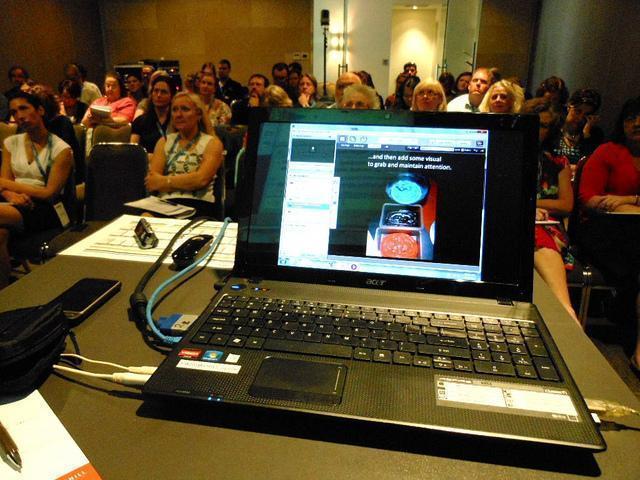What is the purpose of this event?
Pick the right solution, then justify: 'Answer: answer
Rationale: rationale.'
Options: Relax, shop, learn, exercise. Answer: learn.
Rationale: There is a close up shot of a laptop. people are sitting and waiting for someone to speak on stage. 